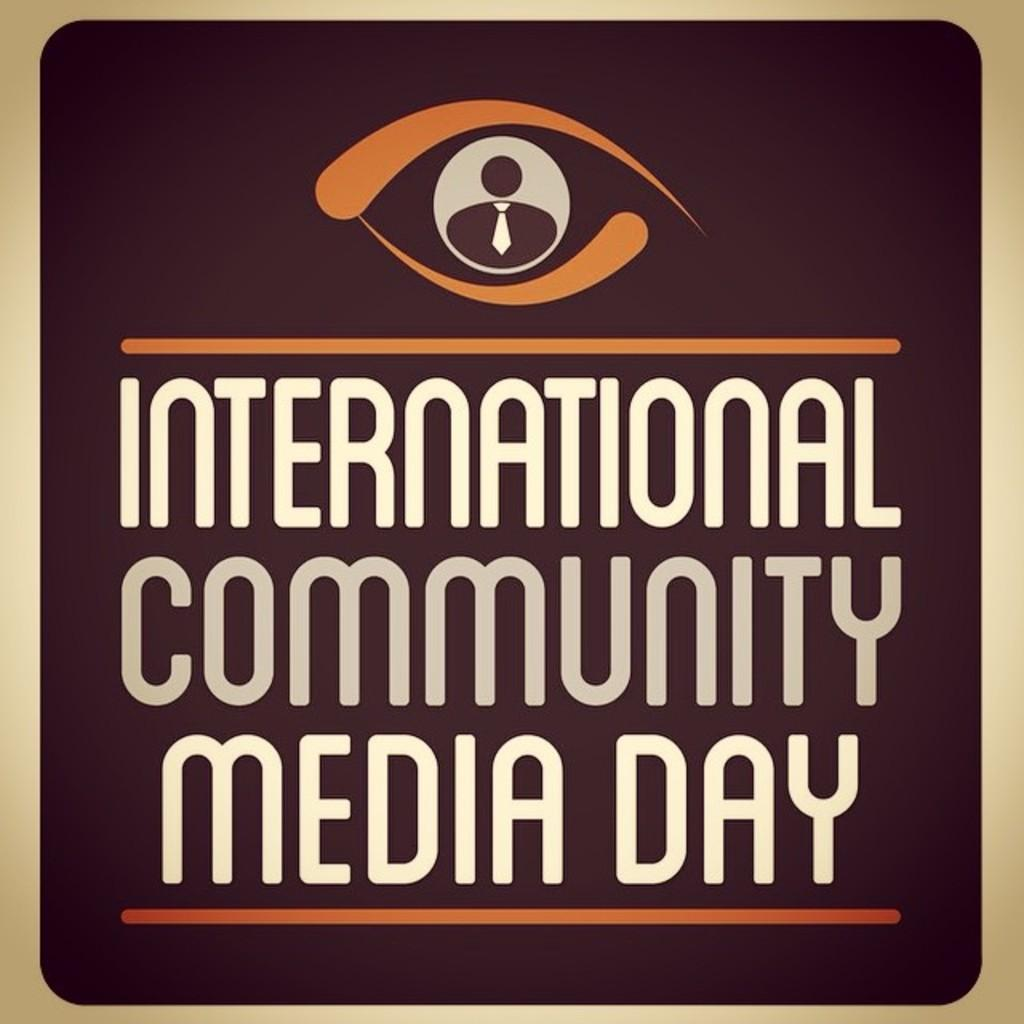Provide a one-sentence caption for the provided image. A brown sign with a logo for International Community Media Day. 